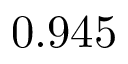<formula> <loc_0><loc_0><loc_500><loc_500>0 . 9 4 5</formula> 